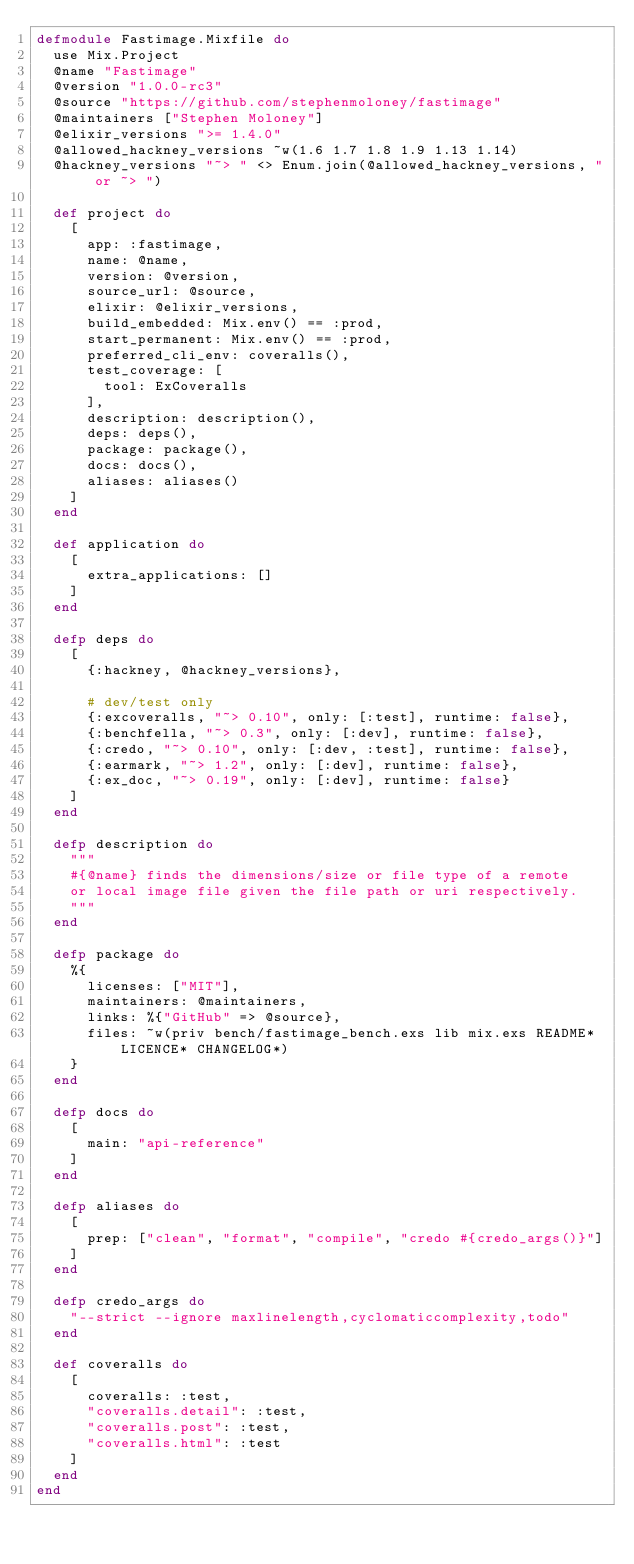<code> <loc_0><loc_0><loc_500><loc_500><_Elixir_>defmodule Fastimage.Mixfile do
  use Mix.Project
  @name "Fastimage"
  @version "1.0.0-rc3"
  @source "https://github.com/stephenmoloney/fastimage"
  @maintainers ["Stephen Moloney"]
  @elixir_versions ">= 1.4.0"
  @allowed_hackney_versions ~w(1.6 1.7 1.8 1.9 1.13 1.14)
  @hackney_versions "~> " <> Enum.join(@allowed_hackney_versions, " or ~> ")

  def project do
    [
      app: :fastimage,
      name: @name,
      version: @version,
      source_url: @source,
      elixir: @elixir_versions,
      build_embedded: Mix.env() == :prod,
      start_permanent: Mix.env() == :prod,
      preferred_cli_env: coveralls(),
      test_coverage: [
        tool: ExCoveralls
      ],
      description: description(),
      deps: deps(),
      package: package(),
      docs: docs(),
      aliases: aliases()
    ]
  end

  def application do
    [
      extra_applications: []
    ]
  end

  defp deps do
    [
      {:hackney, @hackney_versions},

      # dev/test only
      {:excoveralls, "~> 0.10", only: [:test], runtime: false},
      {:benchfella, "~> 0.3", only: [:dev], runtime: false},
      {:credo, "~> 0.10", only: [:dev, :test], runtime: false},
      {:earmark, "~> 1.2", only: [:dev], runtime: false},
      {:ex_doc, "~> 0.19", only: [:dev], runtime: false}
    ]
  end

  defp description do
    """
    #{@name} finds the dimensions/size or file type of a remote
    or local image file given the file path or uri respectively.
    """
  end

  defp package do
    %{
      licenses: ["MIT"],
      maintainers: @maintainers,
      links: %{"GitHub" => @source},
      files: ~w(priv bench/fastimage_bench.exs lib mix.exs README* LICENCE* CHANGELOG*)
    }
  end

  defp docs do
    [
      main: "api-reference"
    ]
  end

  defp aliases do
    [
      prep: ["clean", "format", "compile", "credo #{credo_args()}"]
    ]
  end

  defp credo_args do
    "--strict --ignore maxlinelength,cyclomaticcomplexity,todo"
  end

  def coveralls do
    [
      coveralls: :test,
      "coveralls.detail": :test,
      "coveralls.post": :test,
      "coveralls.html": :test
    ]
  end
end
</code> 